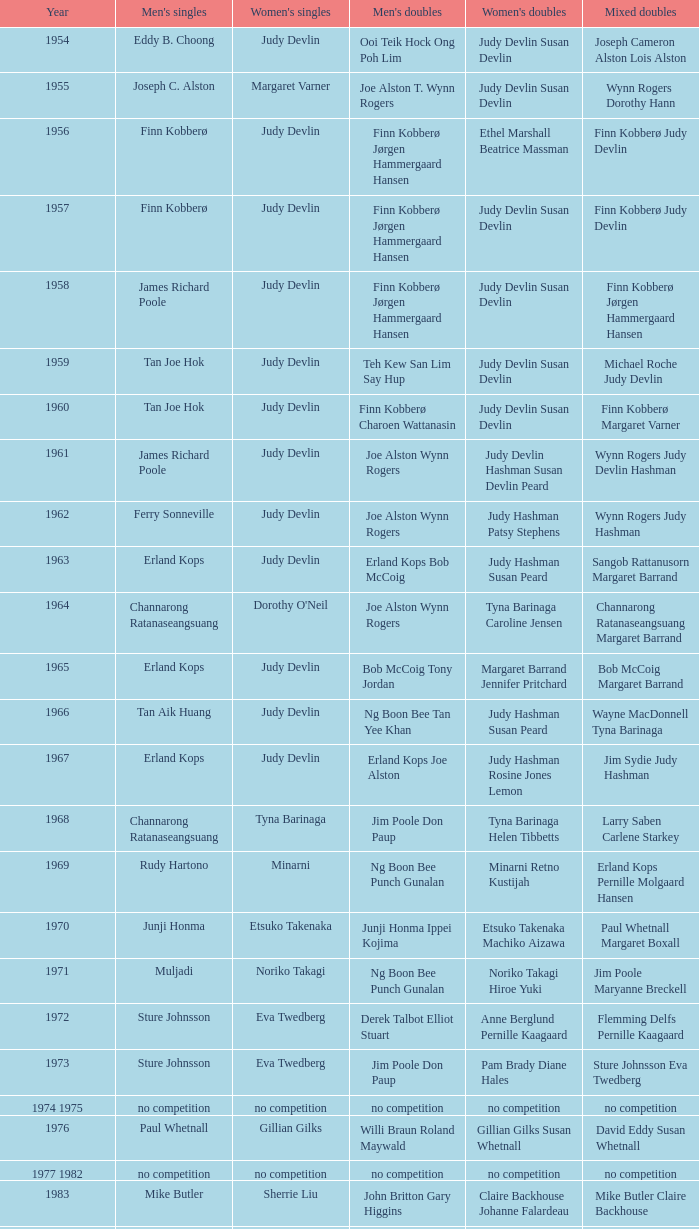Who were the men's doubles winners when the men's singles title was held by muljadi? Ng Boon Bee Punch Gunalan. 